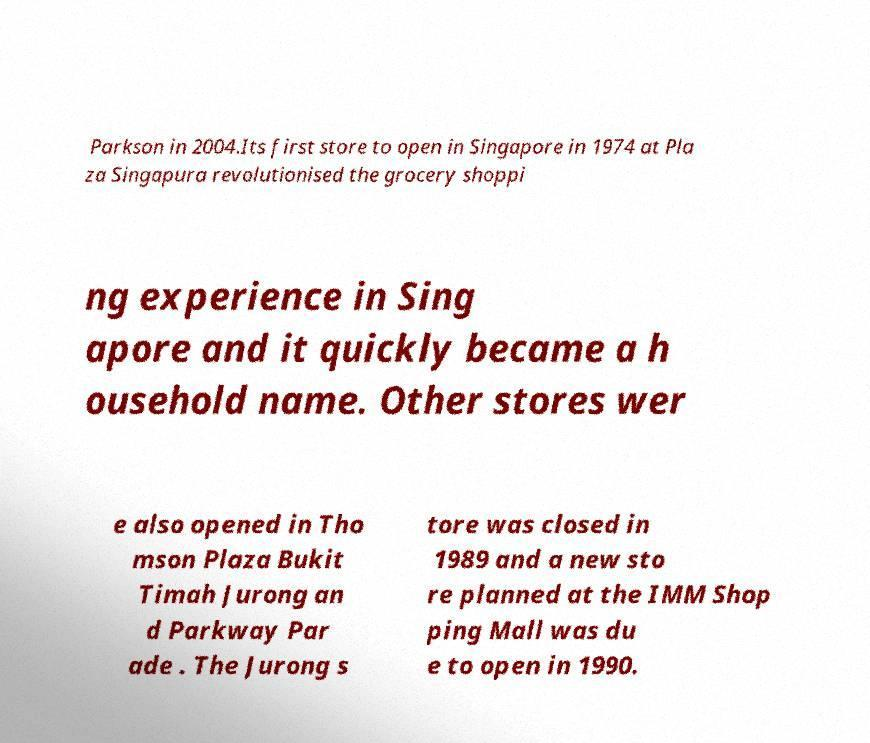Can you read and provide the text displayed in the image?This photo seems to have some interesting text. Can you extract and type it out for me? Parkson in 2004.Its first store to open in Singapore in 1974 at Pla za Singapura revolutionised the grocery shoppi ng experience in Sing apore and it quickly became a h ousehold name. Other stores wer e also opened in Tho mson Plaza Bukit Timah Jurong an d Parkway Par ade . The Jurong s tore was closed in 1989 and a new sto re planned at the IMM Shop ping Mall was du e to open in 1990. 